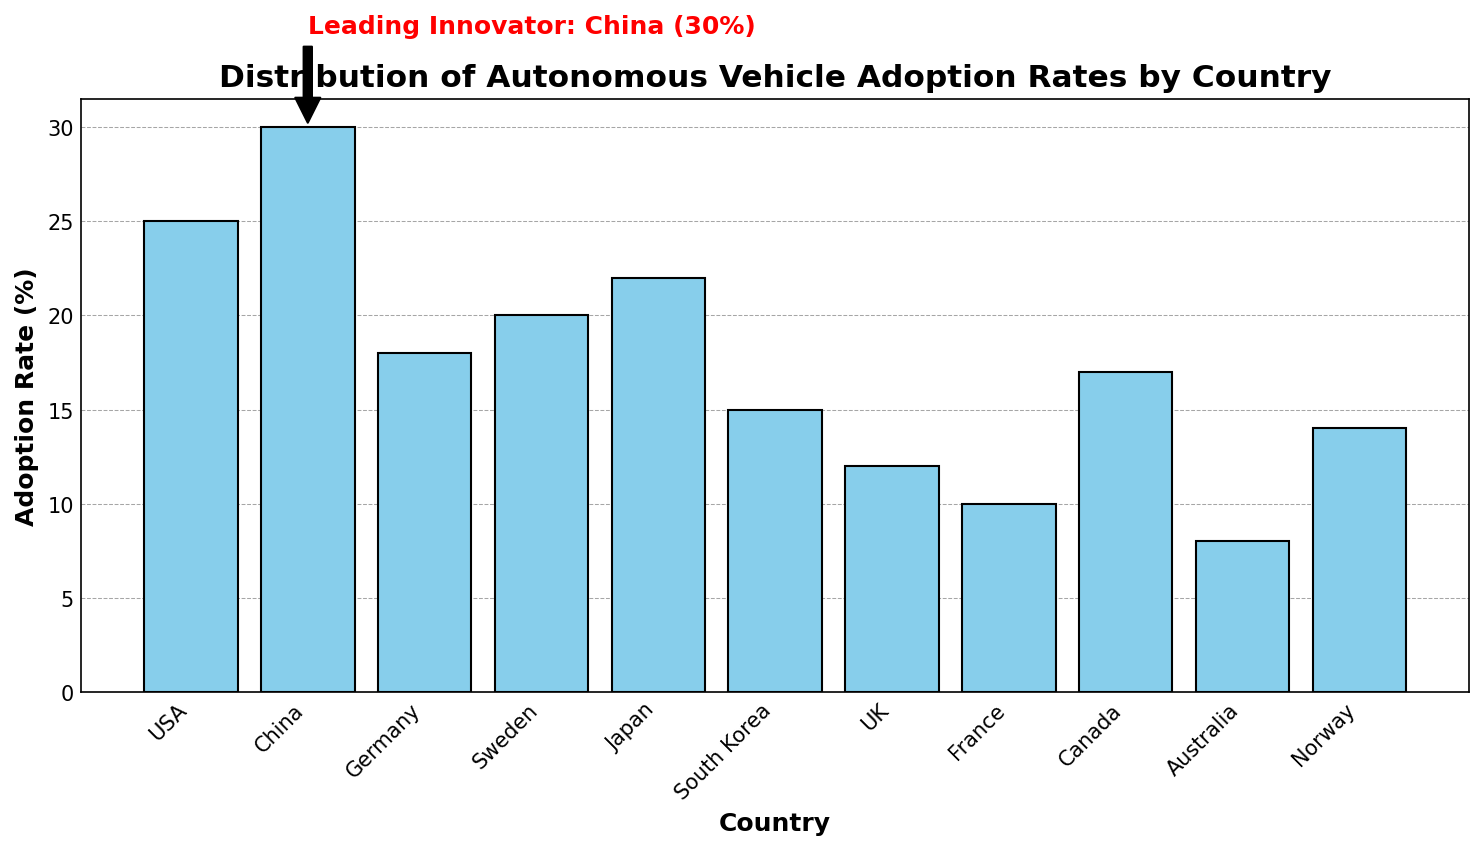Which country has the highest adoption rate of autonomous vehicles? Look at the height of the bars and the annotation in the figure. The country with the highest bar is China, and the annotation confirms this.
Answer: China What's the total adoption rate percentage of the USA, Germany, and Japan combined? Sum the adoption rates of the USA (25), Germany (18), and Japan (22). 25 + 18 + 22 = 65
Answer: 65 Which two countries have the closest adoption rates, and what are those rates? Compare the heights of the bars visually and identify the pairs with minimal differences. Sweden (20%) and Japan (22%) are closest with a difference of 2%.
Answer: Sweden (20%) and Japan (22%) What is the average adoption rate percentage among all the listed countries? Sum the adoption rates of all countries and divide by the number of countries. Sum = 25 + 30 + 18 + 20 + 22 + 15 + 12 + 10 + 17 + 8 + 14 = 191. Number of countries = 11. Average = 191/11 ≈ 17.36
Answer: 17.36 By how much does China's adoption rate exceed the UK's? Subtract the UK's adoption rate (12) from China's adoption rate (30). 30 - 12 = 18
Answer: 18 Which country has the second-lowest adoption rate and what is it? Identify the country with the second shortest bar. The shortest bar is for Australia (8%), and the second shortest is for France (10%).
Answer: France (10%) How many countries have an adoption rate of 20% or higher? Count the bars with heights at or above 20%. The countries are USA (25), China (30), Sweden (20), and Japan (22). Total = 4.
Answer: 4 What is the difference in adoption rates between Canada and Norway? Subtract Norway's adoption rate (14) from Canada's adoption rate (17). 17 - 14 = 3
Answer: 3 